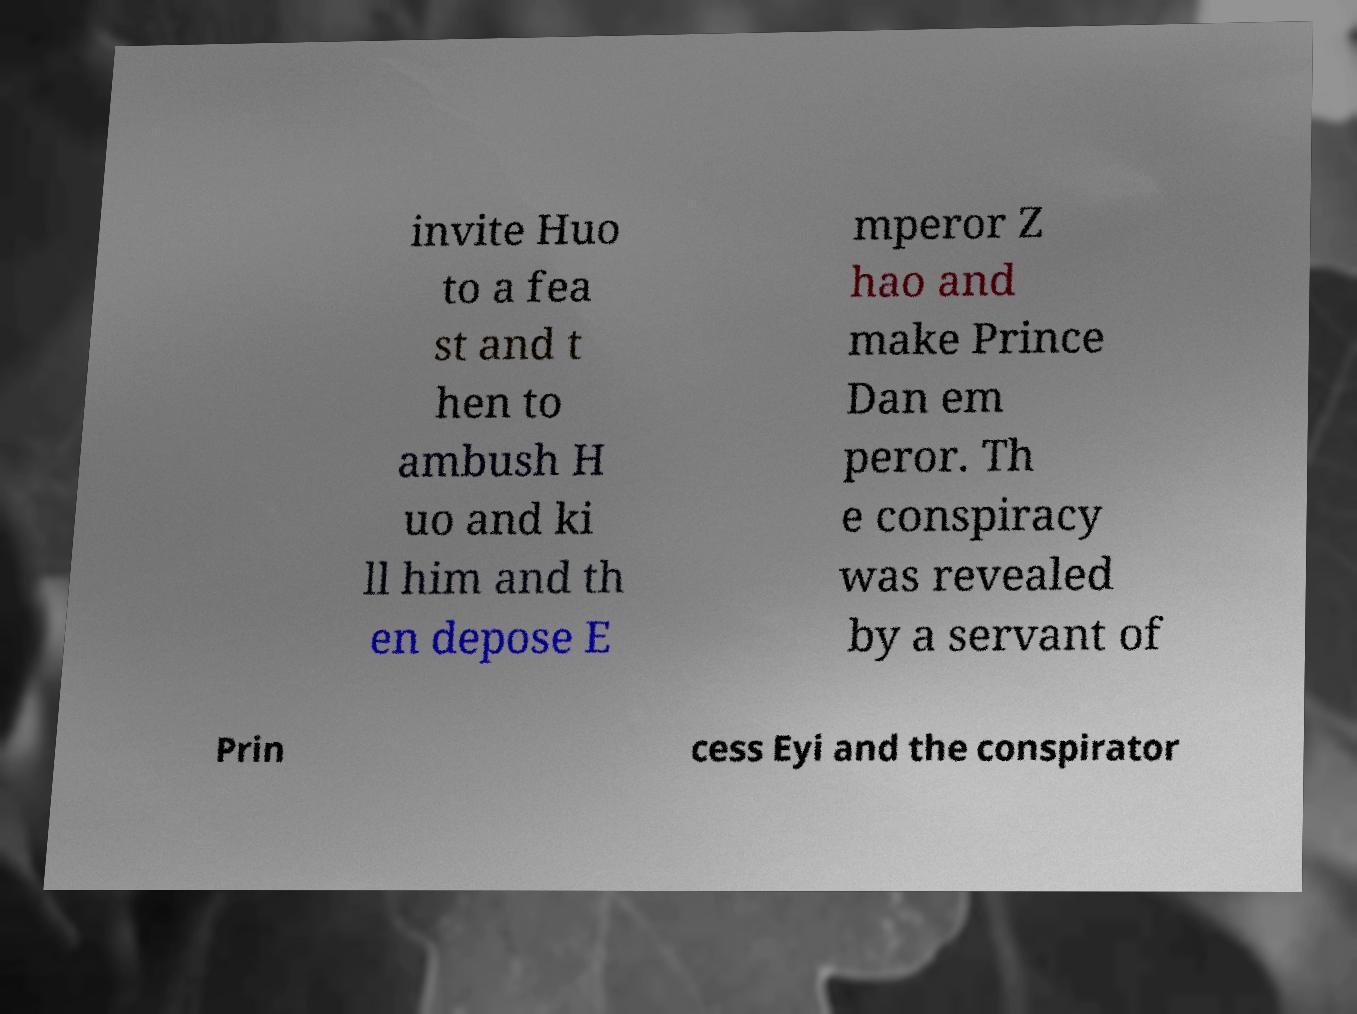Can you accurately transcribe the text from the provided image for me? invite Huo to a fea st and t hen to ambush H uo and ki ll him and th en depose E mperor Z hao and make Prince Dan em peror. Th e conspiracy was revealed by a servant of Prin cess Eyi and the conspirator 